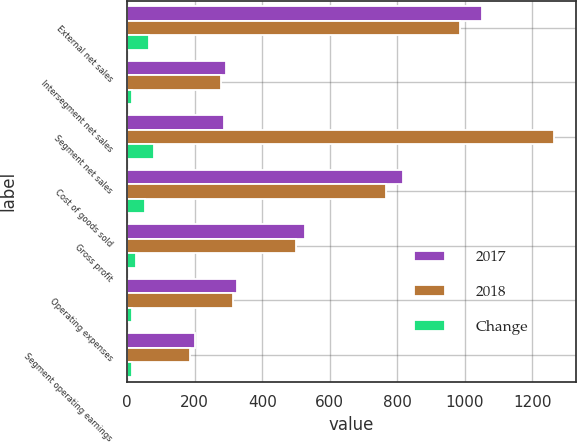Convert chart to OTSL. <chart><loc_0><loc_0><loc_500><loc_500><stacked_bar_chart><ecel><fcel>External net sales<fcel>Intersegment net sales<fcel>Segment net sales<fcel>Cost of goods sold<fcel>Gross profit<fcel>Operating expenses<fcel>Segment operating earnings<nl><fcel>2017<fcel>1051.6<fcel>291.7<fcel>285.3<fcel>817.7<fcel>525.6<fcel>326.3<fcel>199.3<nl><fcel>2018<fcel>986.1<fcel>278.9<fcel>1265<fcel>766.4<fcel>498.6<fcel>312.1<fcel>186.5<nl><fcel>Change<fcel>65.5<fcel>12.8<fcel>78.3<fcel>51.3<fcel>27<fcel>14.2<fcel>12.8<nl></chart> 